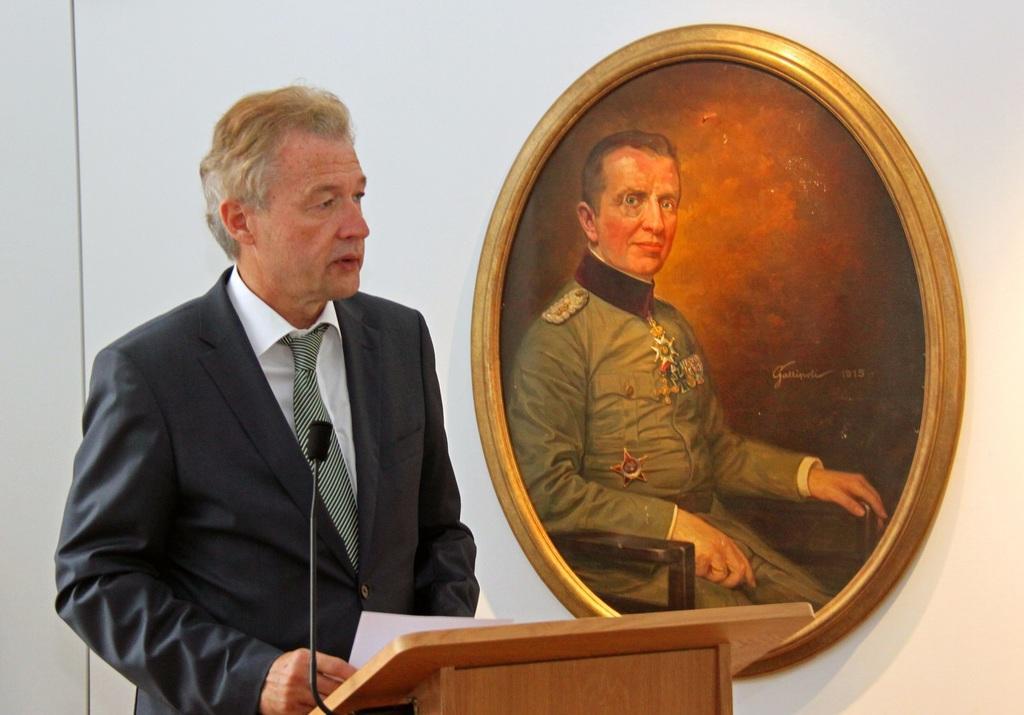How would you summarize this image in a sentence or two? As we can see in the image there is a wall, photo frame, a man wearing black color jacket and holding paper and in the front there is a mic. 